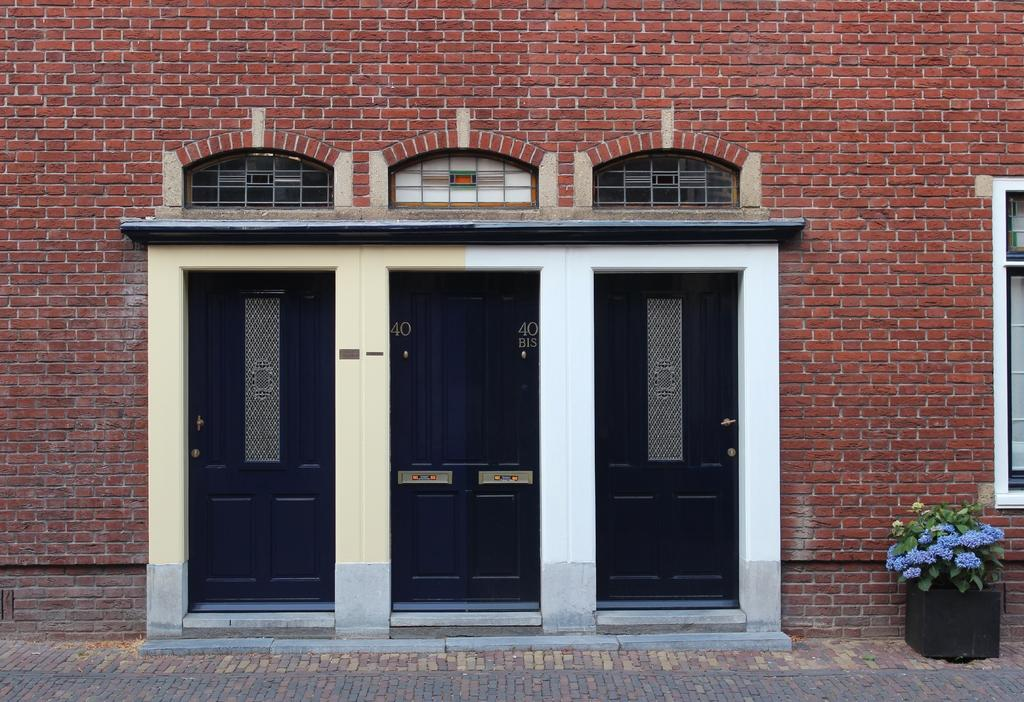What is located in the center of the image? There are doors in the center of the image. What can be seen at the top side of the image? There are windows at the top side of the image. What type of vegetation is present in the image? There are flowers on a plant in the image. Where is the second window located in the image? There is a window on the right side of the image. What type of muscle can be seen flexing in the image? There is no muscle present in the image; it features doors, windows, and flowers on a plant. What rhythm is being played in the background of the image? There is no music or rhythm present in the image. 